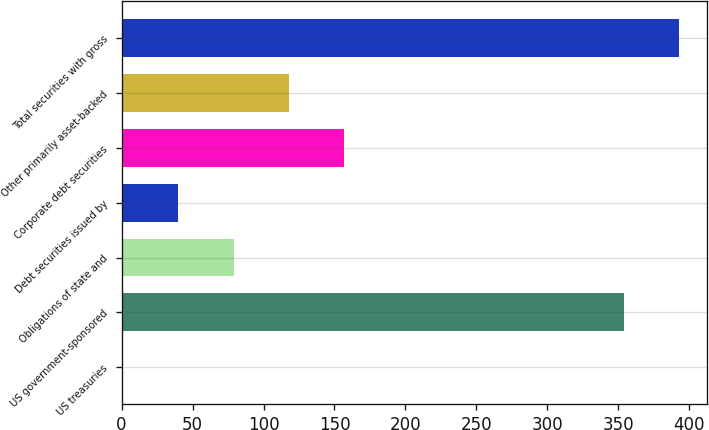<chart> <loc_0><loc_0><loc_500><loc_500><bar_chart><fcel>US treasuries<fcel>US government-sponsored<fcel>Obligations of state and<fcel>Debt securities issued by<fcel>Corporate debt securities<fcel>Other primarily asset-backed<fcel>Total securities with gross<nl><fcel>1<fcel>354<fcel>79<fcel>40<fcel>157<fcel>118<fcel>393<nl></chart> 